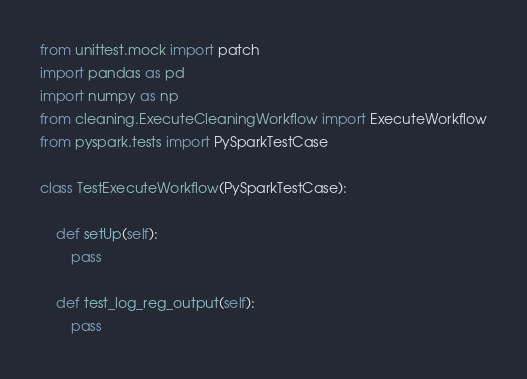<code> <loc_0><loc_0><loc_500><loc_500><_Python_>from unittest.mock import patch
import pandas as pd
import numpy as np
from cleaning.ExecuteCleaningWorkflow import ExecuteWorkflow
from pyspark.tests import PySparkTestCase

class TestExecuteWorkflow(PySparkTestCase):

    def setUp(self):
        pass

    def test_log_reg_output(self):
        pass
</code> 